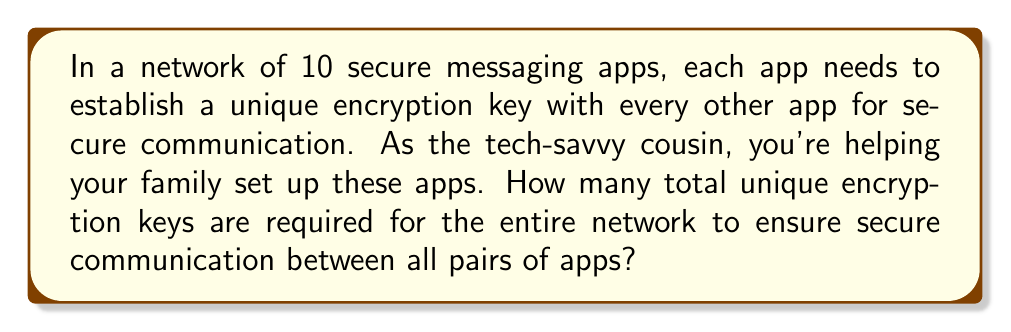Can you solve this math problem? Let's approach this step-by-step:

1) First, we need to understand that each pair of apps requires a unique key. This is a classic combination problem.

2) We're looking for the number of ways to choose 2 apps from 10, where the order doesn't matter (app A to app B is the same as app B to app A).

3) This is represented by the combination formula:

   $$C(n,r) = \frac{n!}{r!(n-r)!}$$

   Where $n$ is the total number of apps and $r$ is the number we're choosing at a time.

4) In this case, $n = 10$ and $r = 2$. Let's substitute these values:

   $$C(10,2) = \frac{10!}{2!(10-2)!} = \frac{10!}{2!8!}$$

5) Expand this:
   
   $$\frac{10 \times 9 \times 8!}{2 \times 1 \times 8!}$$

6) The 8! cancels out in the numerator and denominator:

   $$\frac{10 \times 9}{2 \times 1} = \frac{90}{2} = 45$$

Therefore, 45 unique encryption keys are required for secure communication in the network.
Answer: 45 keys 